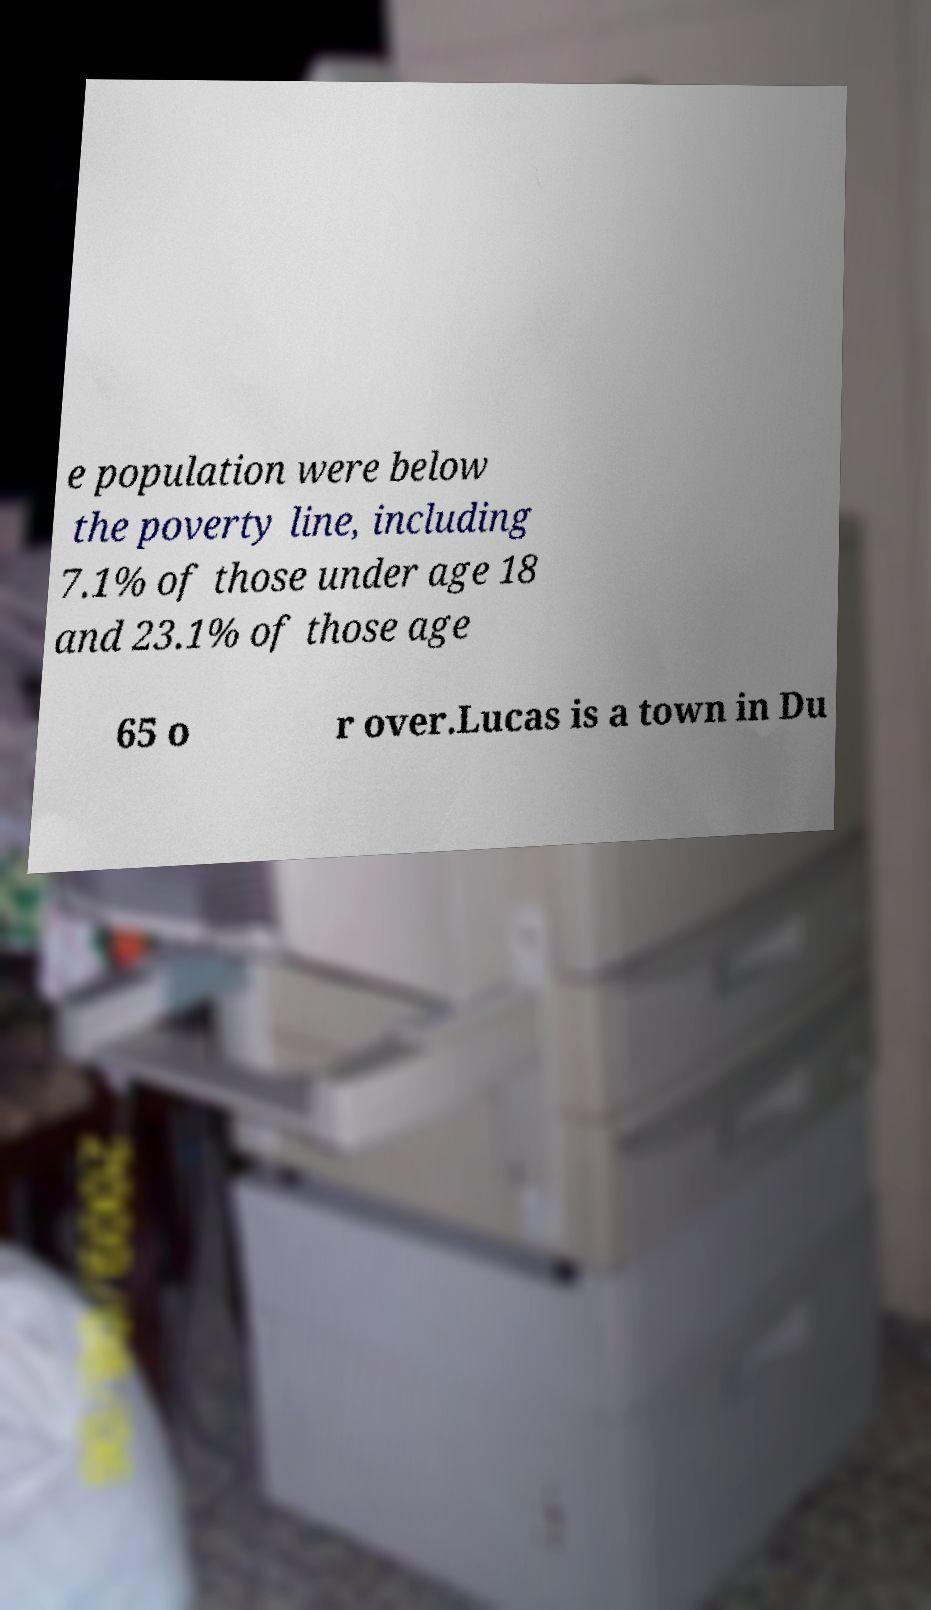Please identify and transcribe the text found in this image. e population were below the poverty line, including 7.1% of those under age 18 and 23.1% of those age 65 o r over.Lucas is a town in Du 